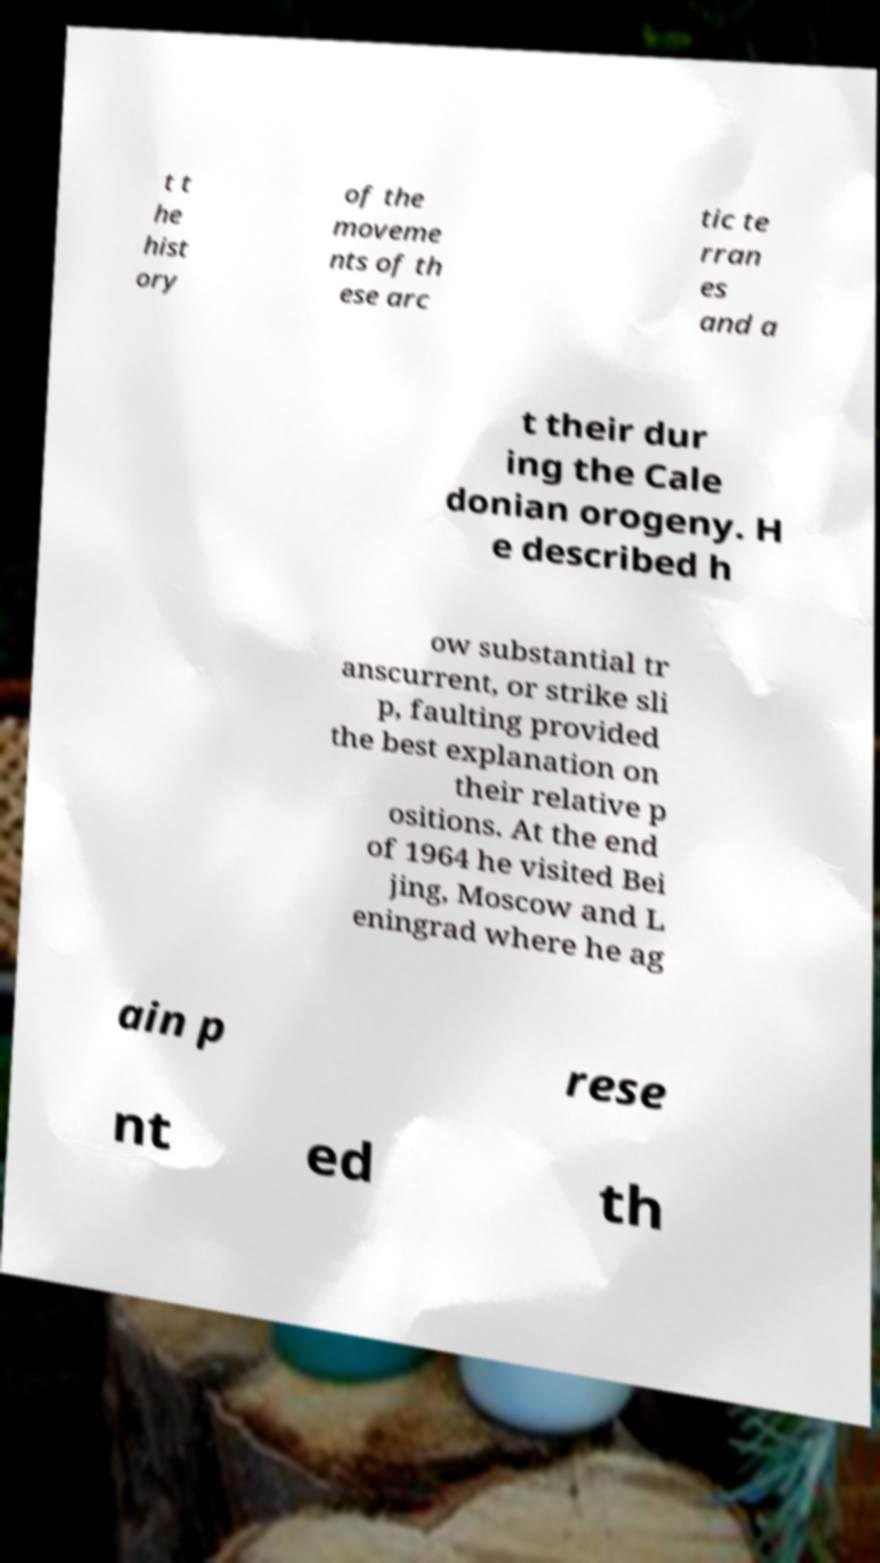Can you accurately transcribe the text from the provided image for me? t t he hist ory of the moveme nts of th ese arc tic te rran es and a t their dur ing the Cale donian orogeny. H e described h ow substantial tr anscurrent, or strike sli p, faulting provided the best explanation on their relative p ositions. At the end of 1964 he visited Bei jing, Moscow and L eningrad where he ag ain p rese nt ed th 